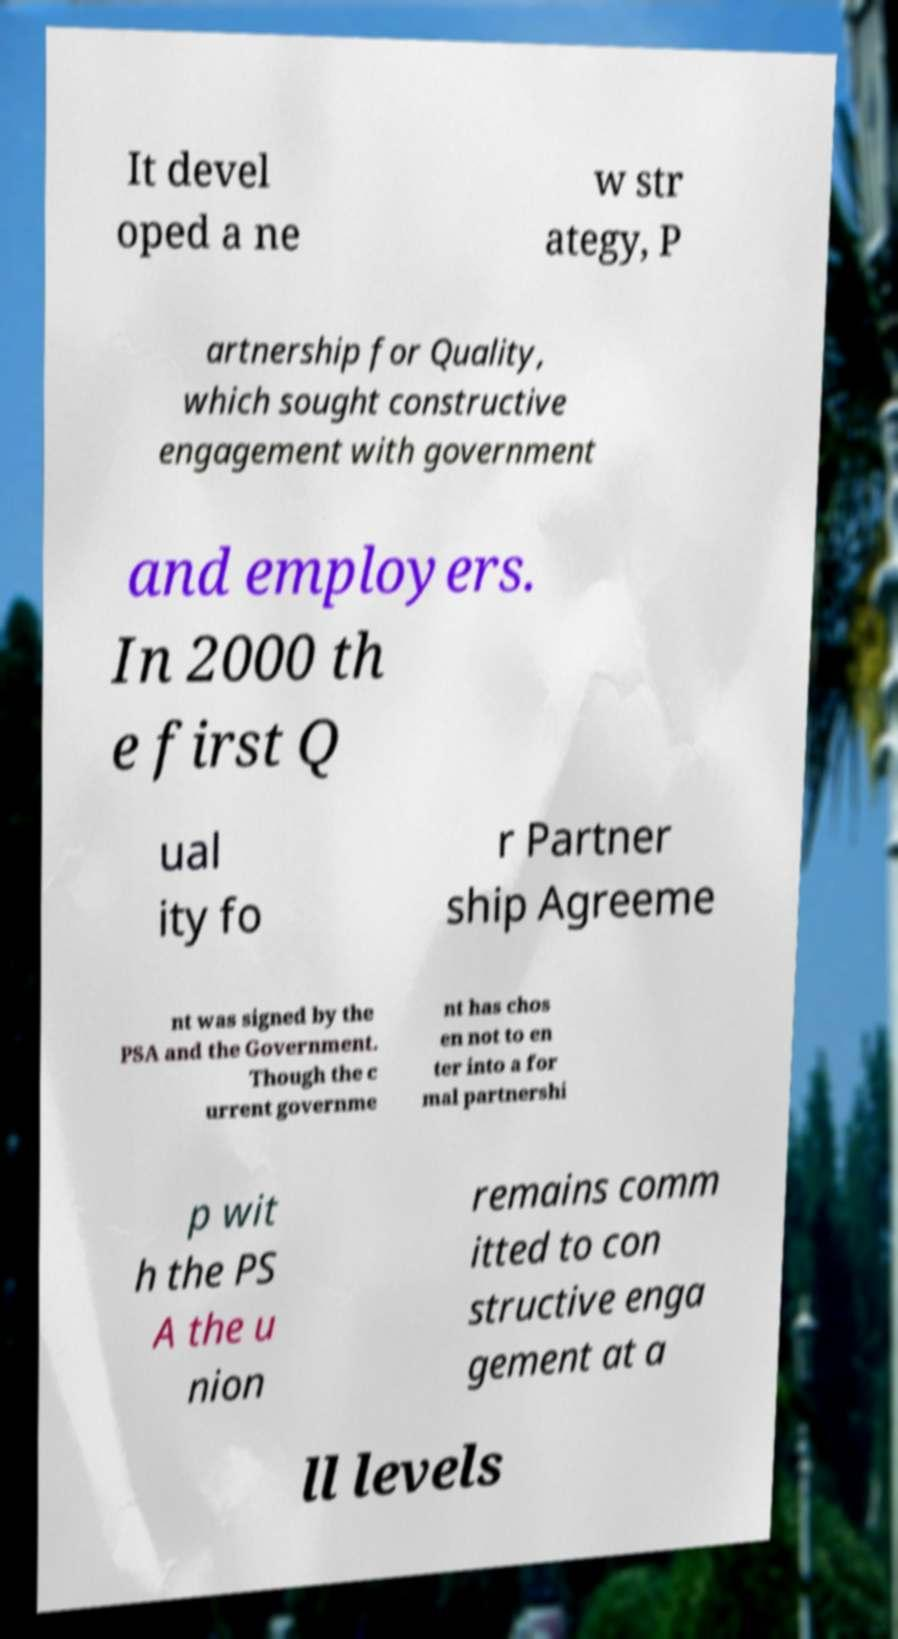I need the written content from this picture converted into text. Can you do that? It devel oped a ne w str ategy, P artnership for Quality, which sought constructive engagement with government and employers. In 2000 th e first Q ual ity fo r Partner ship Agreeme nt was signed by the PSA and the Government. Though the c urrent governme nt has chos en not to en ter into a for mal partnershi p wit h the PS A the u nion remains comm itted to con structive enga gement at a ll levels 